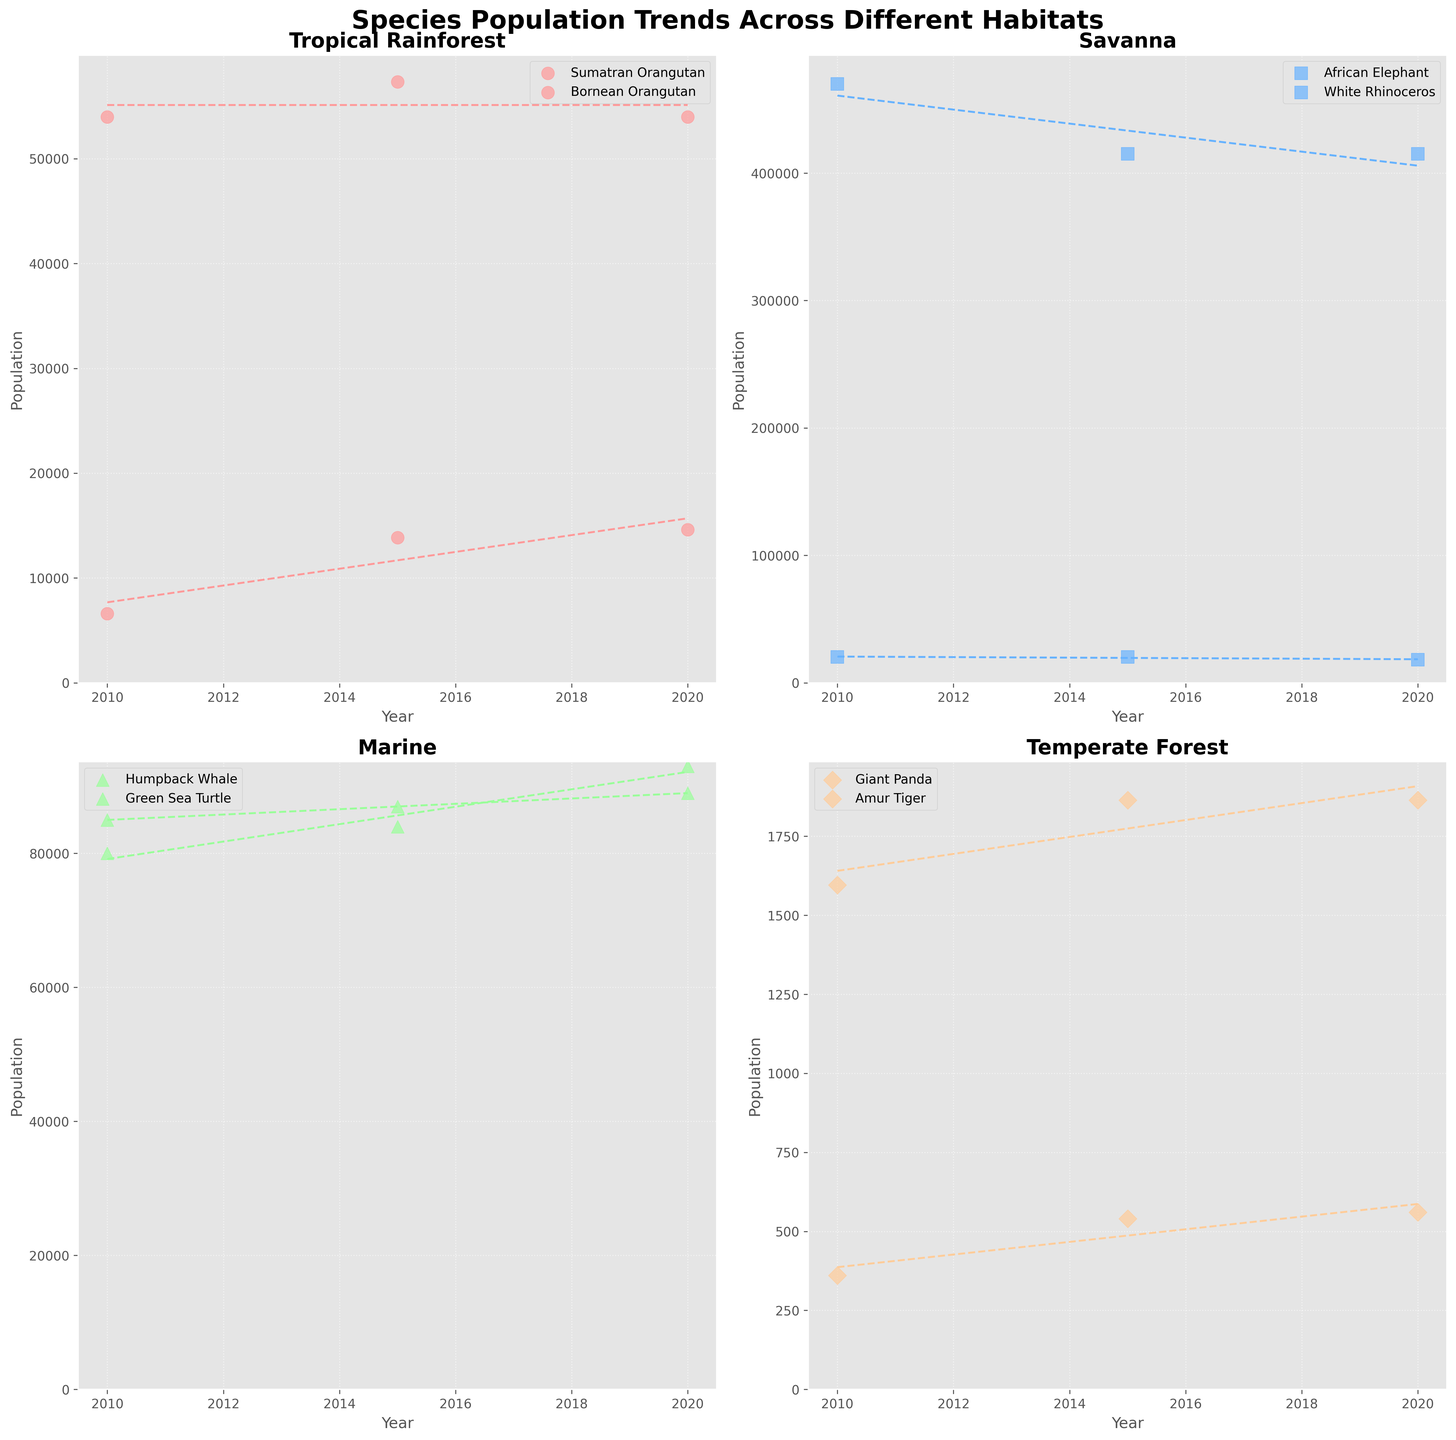What is the total population of Sumatran Orangutans in the Tropical Rainforest habitat in 2020? Look at the subplot for the Tropical Rainforest habitat. Focus on the Sumatran Orangutan species data for the year 2020. The population is given directly.
Answer: 14613 Which species in the Savanna habitat had a decreasing population trend from 2010 to 2020? Observe the trend lines and population points for species in the Savanna subplot. The African Elephant shows a clear decreasing population trend over the years.
Answer: African Elephant How did the population of the Giant Panda change from 2010 to 2015? Look at the subplot for the Temperate Forest habitat. Focus on the Giant Panda's points and compare the population in 2010 and 2015. The population increased from 1596 to 1864.
Answer: Increased Which species has the highest population in the Marine habitat in 2020? Look at the subplot for the Marine habitat. Compare the population points of the Humpback Whale and Green Sea Turtle for the year 2020. The Humpback Whale has the highest population.
Answer: Humpback Whale What is the difference in population between the African Elephant and White Rhinoceros in the Savanna habitat in 2020? Find the populations of the African Elephant and White Rhinoceros in 2020 in the Savanna subplot. Subtract the population of the White Rhinoceros (18067) from the African Elephant (415000).
Answer: 396933 Which habitat had the species with the lowest population in 2010? Compare the population points of all species in each habitat for the year 2010. The Amur Tiger in the Temperate Forest subplot has the lowest population at 360.
Answer: Temperate Forest How many species in the Tropical Rainforest habitat had an increasing population trend from 2010 to 2020? Observe the trend lines for each species in the Tropical Rainforest subplot from 2010 to 2020. Both the Sumatran Orangutan and Bornean Orangutan exhibit increasing trends.
Answer: 2 What is the average population of the Green Sea Turtle in the Marine habitat across 2010, 2015, and 2020? Find the population points for the Green Sea Turtle in 2010, 2015, and 2020 in the Marine subplot. Add them (85000 + 87000 + 89000) and divide by the number of years (3).
Answer: 87000 Which species in the Temperate Forest habitat had the highest increase in population from 2010 to 2020? Look at the Temperate Forest subplot and calculate the population increase for each species from 2010 to 2020. The Amur Tiger's increase (360 to 560) is higher than the Giant Panda's increase (1596 to 1864).
Answer: Amur Tiger 